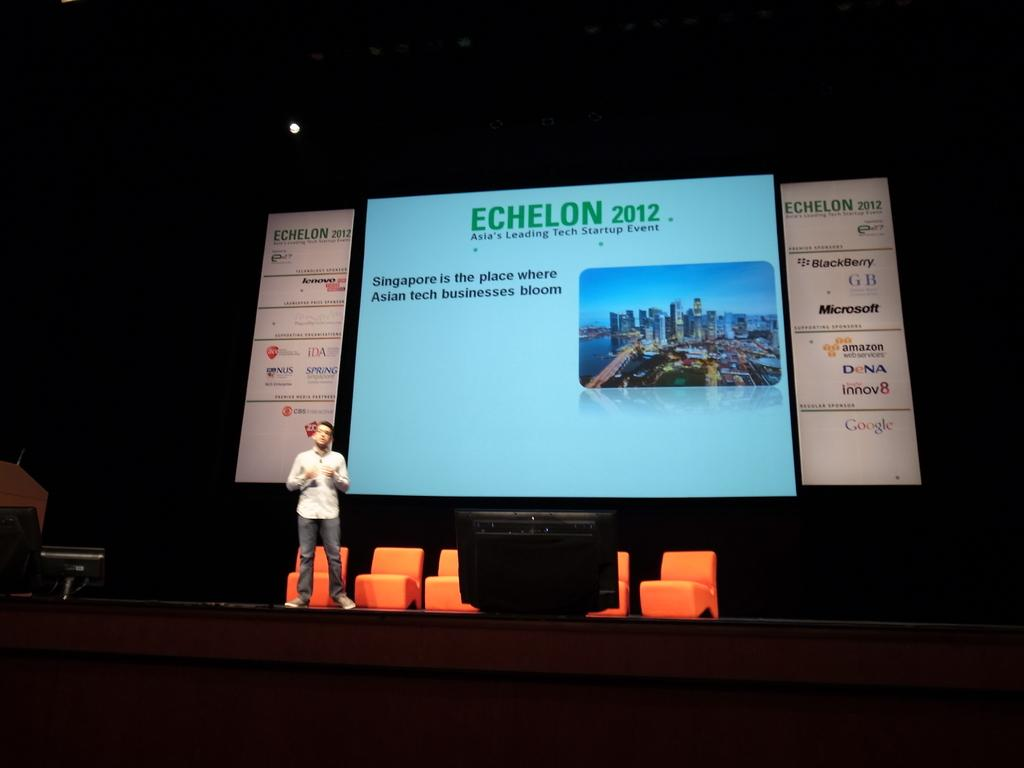<image>
Summarize the visual content of the image. A man speaks on stage at Echelon 2012. 